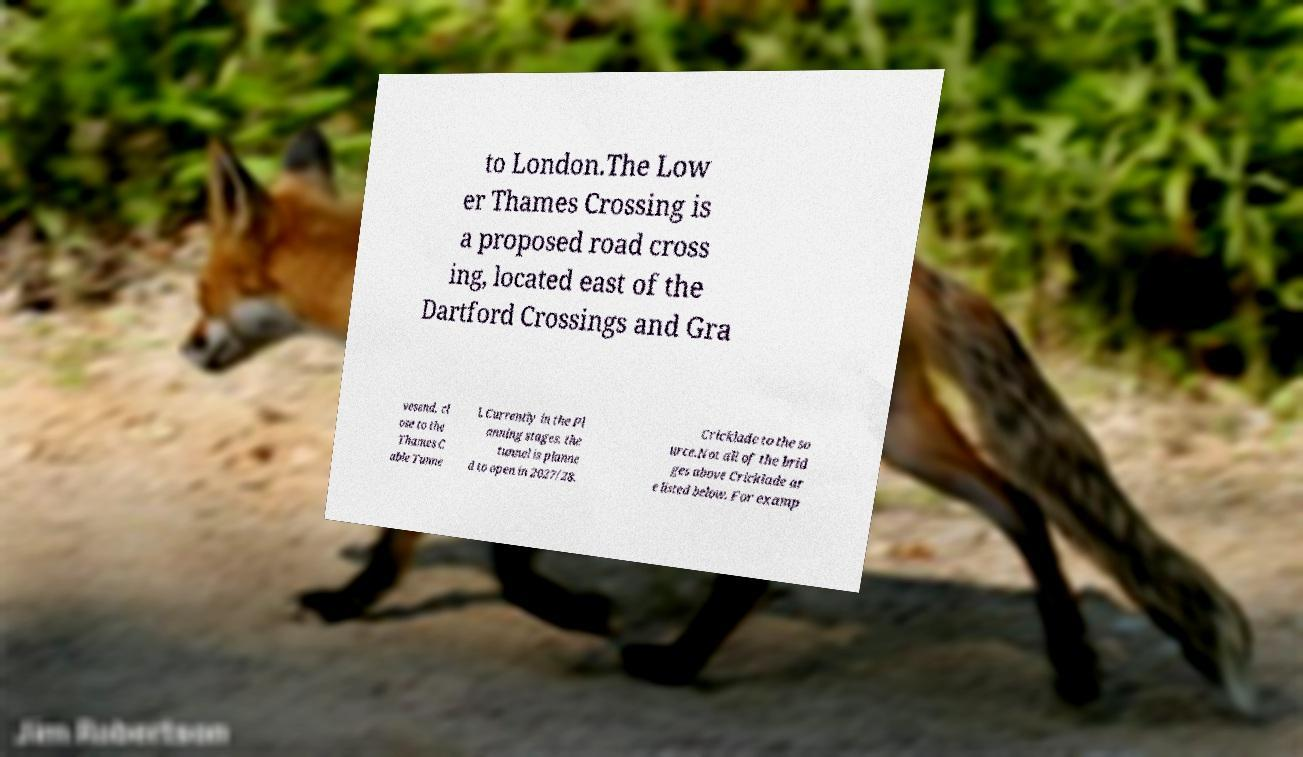What messages or text are displayed in this image? I need them in a readable, typed format. to London.The Low er Thames Crossing is a proposed road cross ing, located east of the Dartford Crossings and Gra vesend, cl ose to the Thames C able Tunne l. Currently in the Pl anning stages, the tunnel is planne d to open in 2027/28. Cricklade to the so urce.Not all of the brid ges above Cricklade ar e listed below. For examp 